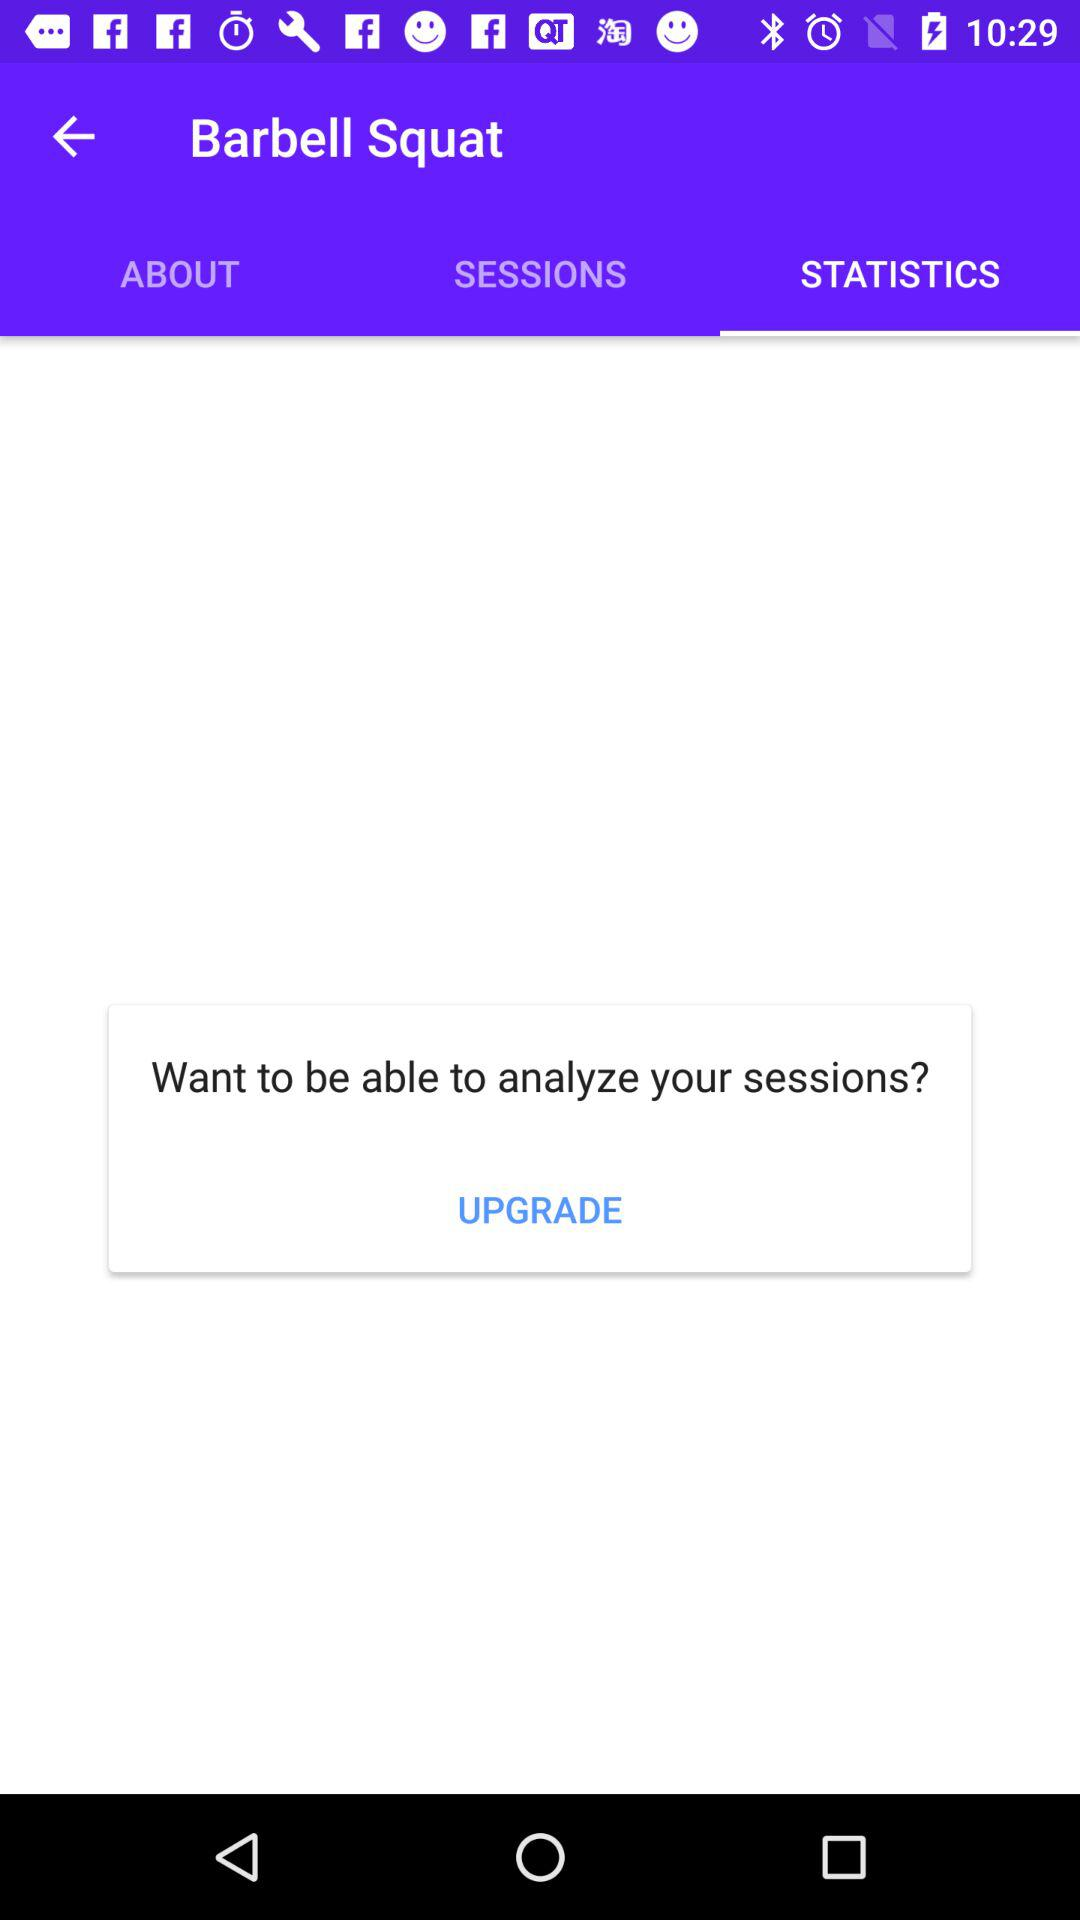Which tab is selected? The selected tab is "STATISTICS". 